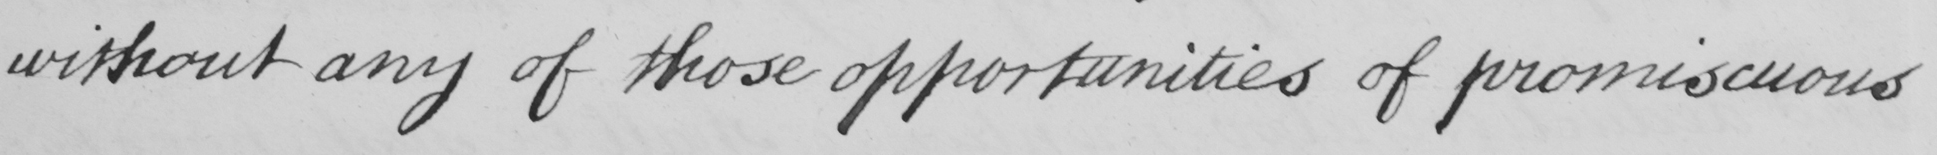Can you read and transcribe this handwriting? without any of those opportunities of promiscuous 